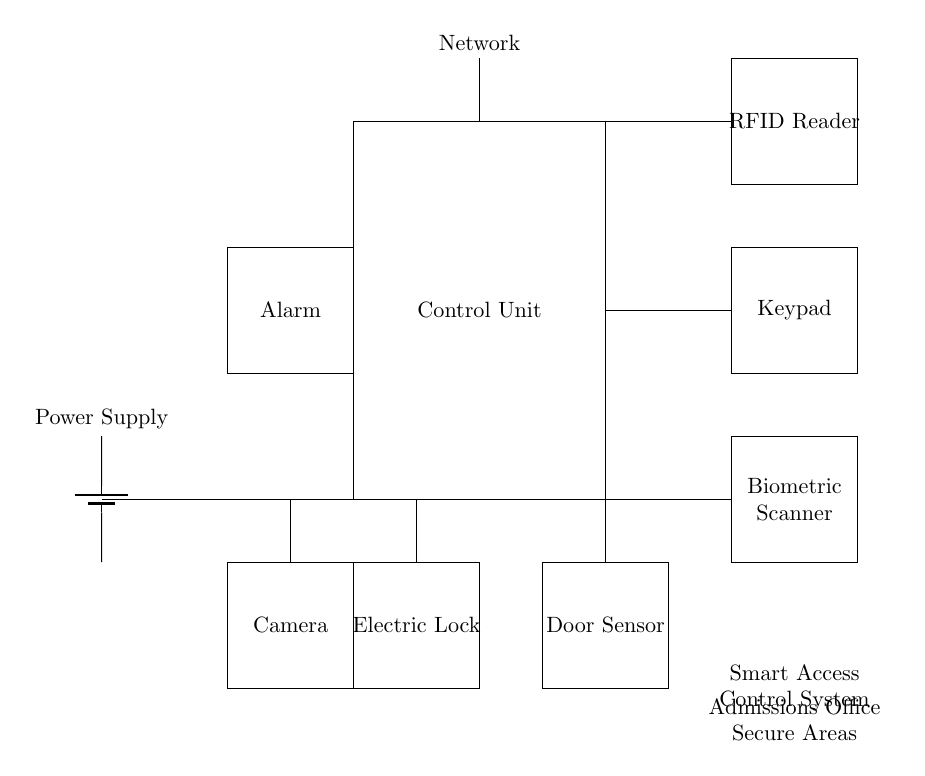What component is used for user authentication? The user authentication in the smart access control system is managed by the RFID reader, keypad, and biometric scanner. This indicates that there are multiple methods in place for ensuring only authorized personnel can access the secure area.
Answer: RFID reader, keypad, biometric scanner What powers the entire system? The power supply component is responsible for supplying power to the entire circuit. It is indicated in the diagram as providing voltage to the other components necessary for the smart access control system to function.
Answer: Power Supply How many user authentication methods are there? The circuit diagram indicates three user authentication methods: the RFID reader, keypad, and biometric scanner. These methods enhance security by providing alternatives for verification.
Answer: Three What does the electric lock do? The electric lock is the component that physically secures the door, allowing or denying entry based on successful verification of the authentication methods. It plays a critical role in the overall security of the admissions office area.
Answer: Secures the door Which component alerts users of an unauthorized access attempt? The alarm component serves as a notification system for unauthorized access attempts. When triggered, it would alert personnel about a security breach, making it an important feature in the access control system.
Answer: Alarm What role does the camera play in this circuit? The camera is included in the circuit as a surveillance device, which can provide visual records of who accesses the secure areas. This adds an extra layer of security and monitoring within the system.
Answer: Surveillance How is the door status monitored? The door sensor indicates whether the door is open or closed. It interacts with the electric lock to ensure that the system is aware of the door's status and can make decisions accordingly regarding access.
Answer: Door Sensor 